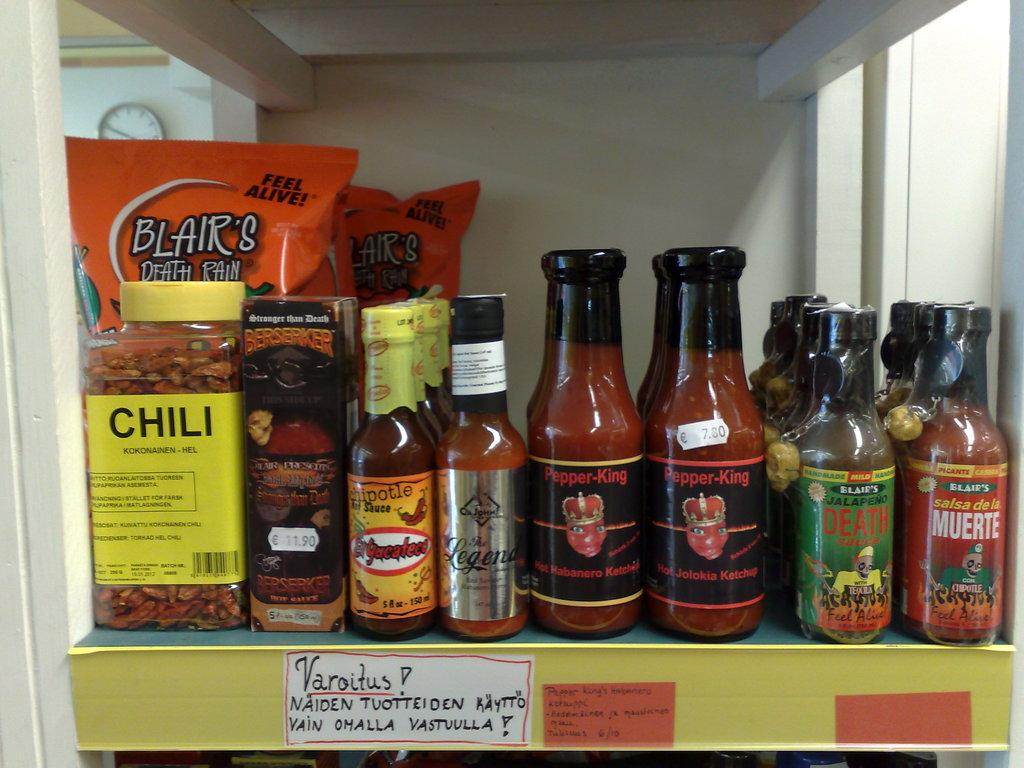<image>
Present a compact description of the photo's key features. A shelf with different sized bottles lined up at the end the largest bottle reads Chili. 